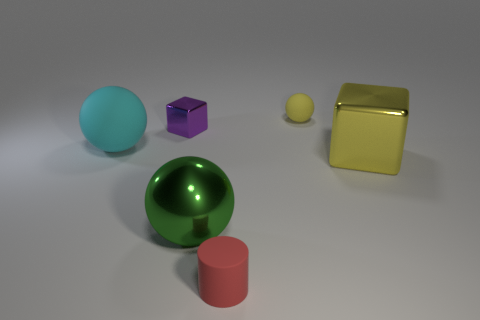Add 4 purple shiny cubes. How many objects exist? 10 Subtract all tiny yellow matte balls. How many balls are left? 2 Subtract all cyan spheres. How many spheres are left? 2 Subtract all cylinders. How many objects are left? 5 Add 6 small purple things. How many small purple things are left? 7 Add 3 purple blocks. How many purple blocks exist? 4 Subtract 0 brown cylinders. How many objects are left? 6 Subtract 1 blocks. How many blocks are left? 1 Subtract all gray cubes. Subtract all blue cylinders. How many cubes are left? 2 Subtract all green balls. How many cyan cylinders are left? 0 